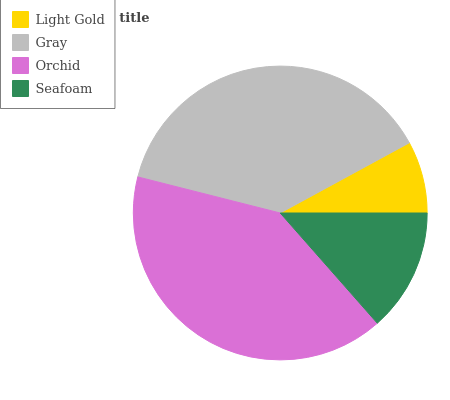Is Light Gold the minimum?
Answer yes or no. Yes. Is Orchid the maximum?
Answer yes or no. Yes. Is Gray the minimum?
Answer yes or no. No. Is Gray the maximum?
Answer yes or no. No. Is Gray greater than Light Gold?
Answer yes or no. Yes. Is Light Gold less than Gray?
Answer yes or no. Yes. Is Light Gold greater than Gray?
Answer yes or no. No. Is Gray less than Light Gold?
Answer yes or no. No. Is Gray the high median?
Answer yes or no. Yes. Is Seafoam the low median?
Answer yes or no. Yes. Is Light Gold the high median?
Answer yes or no. No. Is Light Gold the low median?
Answer yes or no. No. 